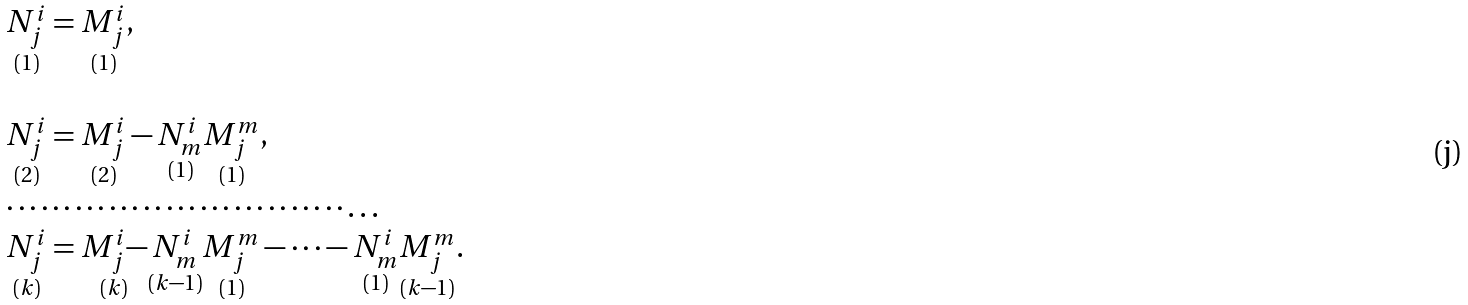<formula> <loc_0><loc_0><loc_500><loc_500>\begin{array} { l } \underset { ( 1 ) } { N _ { j } ^ { i } } = \underset { ( 1 ) } { M _ { j } ^ { i } } , \\ \\ \underset { ( 2 ) } { N _ { j } ^ { i } } = \underset { ( 2 ) } { M _ { j } ^ { i } } - \underset { ( 1 ) } { N _ { m } ^ { i } } \underset { ( 1 ) } { M _ { j } ^ { m } } , \\ \cdots \cdots \cdots \cdots \cdots \cdots \cdots \cdots \cdots \cdots \dots \\ \underset { ( k ) } { N _ { j } ^ { i } } = \underset { ( k ) } { M _ { j } ^ { i } - } \underset { ( k - 1 ) } { N _ { m } ^ { i } } \underset { ( 1 ) } { M _ { j } ^ { m } } - \dots - \underset { ( 1 ) } { N _ { m } ^ { i } } \underset { ( k - 1 ) } { M _ { j } ^ { m } } . \end{array}</formula> 